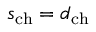Convert formula to latex. <formula><loc_0><loc_0><loc_500><loc_500>s _ { c h } = d _ { c h }</formula> 